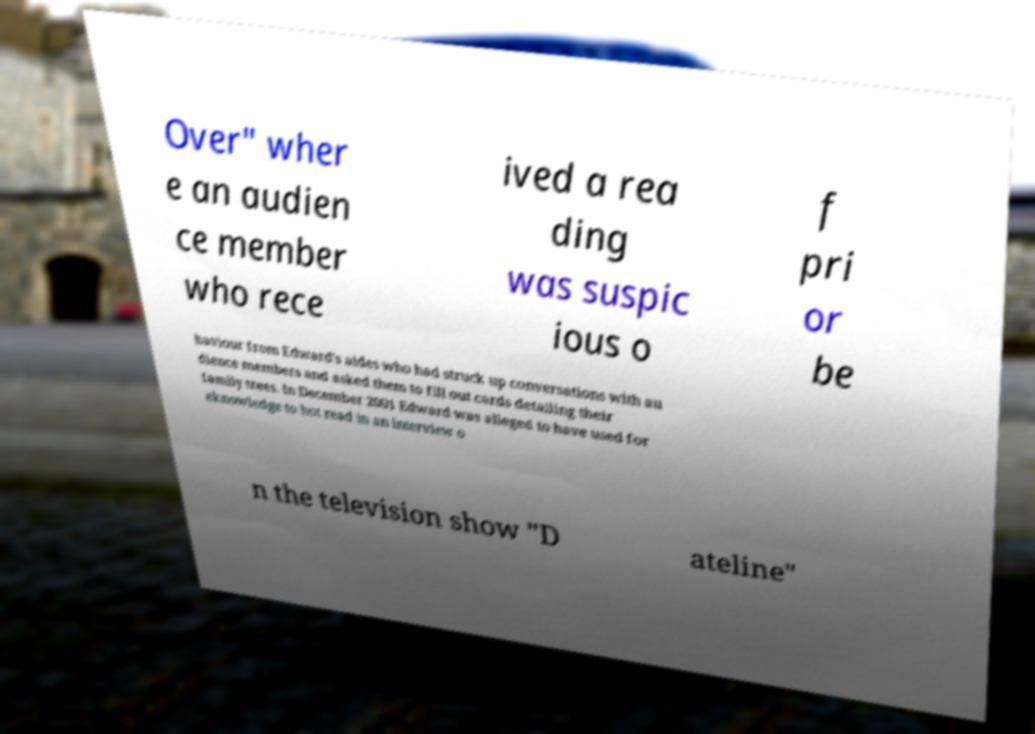Could you assist in decoding the text presented in this image and type it out clearly? Over" wher e an audien ce member who rece ived a rea ding was suspic ious o f pri or be haviour from Edward's aides who had struck up conversations with au dience members and asked them to fill out cards detailing their family trees. In December 2001 Edward was alleged to have used for eknowledge to hot read in an interview o n the television show "D ateline" 